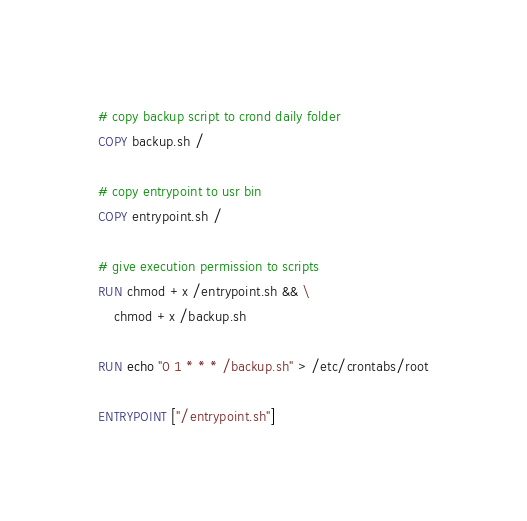<code> <loc_0><loc_0><loc_500><loc_500><_Dockerfile_>
# copy backup script to crond daily folder
COPY backup.sh /

# copy entrypoint to usr bin
COPY entrypoint.sh /

# give execution permission to scripts
RUN chmod +x /entrypoint.sh && \
    chmod +x /backup.sh

RUN echo "0 1 * * * /backup.sh" > /etc/crontabs/root

ENTRYPOINT ["/entrypoint.sh"]</code> 